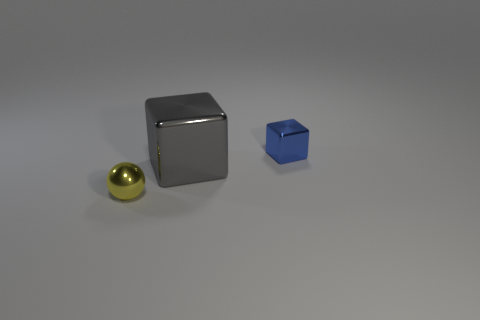What number of large objects are the same shape as the tiny blue thing?
Offer a very short reply. 1. What shape is the yellow object that is made of the same material as the large gray cube?
Offer a terse response. Sphere. How many red objects are tiny rubber spheres or small metal objects?
Offer a very short reply. 0. There is a tiny blue block; are there any shiny balls behind it?
Your answer should be compact. No. There is a tiny thing that is behind the small yellow metallic ball; is its shape the same as the small metallic object to the left of the tiny blue metallic block?
Offer a terse response. No. There is a large thing that is the same shape as the small blue metallic object; what is its material?
Provide a short and direct response. Metal. How many cubes are either small things or large gray things?
Give a very brief answer. 2. How many blue balls are the same material as the large block?
Offer a terse response. 0. Are the block that is in front of the tiny blue metal thing and the thing to the left of the big metallic block made of the same material?
Provide a succinct answer. Yes. How many shiny objects are on the left side of the small shiny object that is to the right of the object that is in front of the big gray cube?
Make the answer very short. 2. 